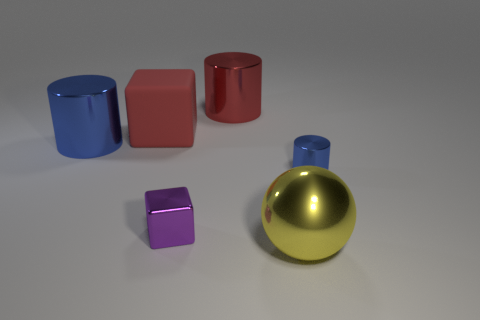What is the shape of the metallic thing that is the same size as the shiny block?
Provide a succinct answer. Cylinder. What is the color of the small cylinder that is made of the same material as the large ball?
Keep it short and to the point. Blue. Does the tiny purple thing have the same shape as the large matte thing behind the yellow ball?
Keep it short and to the point. Yes. There is a red block that is the same size as the red metal cylinder; what is its material?
Your answer should be very brief. Rubber. Are there any things that have the same color as the tiny cylinder?
Provide a succinct answer. Yes. What shape is the metallic object that is behind the small cylinder and to the left of the red metal thing?
Provide a short and direct response. Cylinder. How many large blue things have the same material as the small blue object?
Offer a terse response. 1. Is the number of big yellow shiny balls that are on the left side of the big red metallic cylinder less than the number of small things behind the yellow shiny ball?
Make the answer very short. Yes. What is the material of the cylinder left of the red shiny cylinder left of the blue cylinder that is on the right side of the large blue shiny object?
Ensure brevity in your answer.  Metal. There is a shiny object that is in front of the large red matte object and behind the small blue cylinder; what size is it?
Your answer should be very brief. Large. 